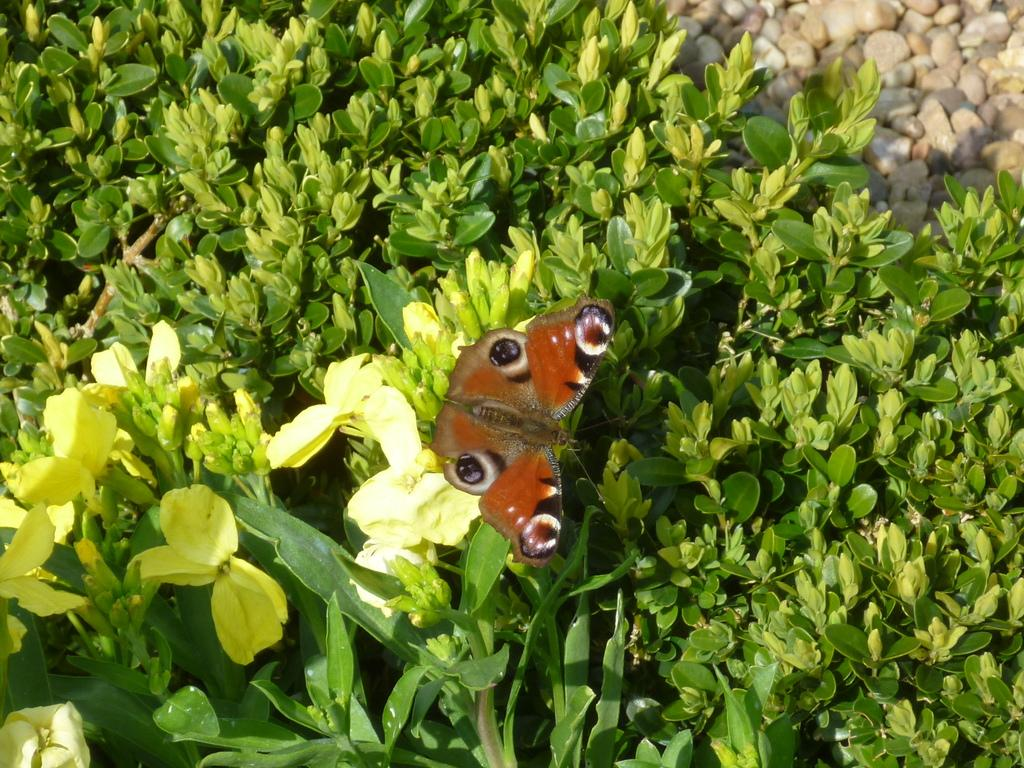What is on the flower in the image? There is a butterfly on a flower in the image. What else can be seen in the image besides the butterfly? There are plants in the image. Where are the stones located in the image? The stones are visible at the top right side of the image. What type of scissors can be seen cutting the blade of grass in the image? There are no scissors or blades of grass present in the image. 